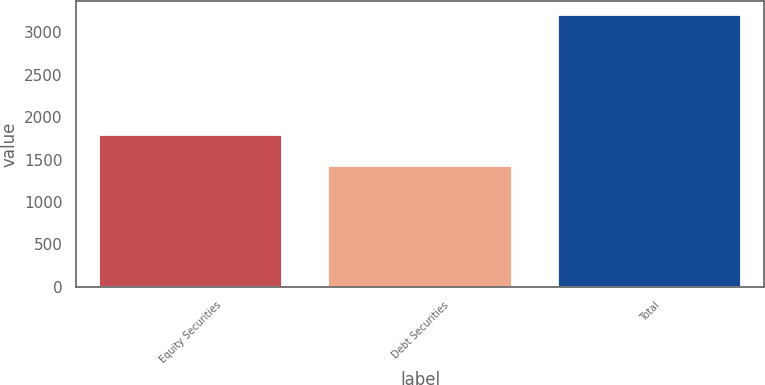Convert chart to OTSL. <chart><loc_0><loc_0><loc_500><loc_500><bar_chart><fcel>Equity Securities<fcel>Debt Securities<fcel>Total<nl><fcel>1788<fcel>1423<fcel>3211<nl></chart> 